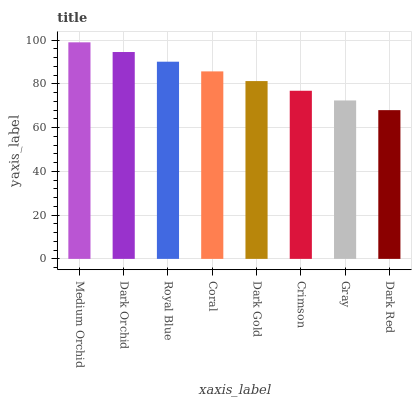Is Dark Red the minimum?
Answer yes or no. Yes. Is Medium Orchid the maximum?
Answer yes or no. Yes. Is Dark Orchid the minimum?
Answer yes or no. No. Is Dark Orchid the maximum?
Answer yes or no. No. Is Medium Orchid greater than Dark Orchid?
Answer yes or no. Yes. Is Dark Orchid less than Medium Orchid?
Answer yes or no. Yes. Is Dark Orchid greater than Medium Orchid?
Answer yes or no. No. Is Medium Orchid less than Dark Orchid?
Answer yes or no. No. Is Coral the high median?
Answer yes or no. Yes. Is Dark Gold the low median?
Answer yes or no. Yes. Is Crimson the high median?
Answer yes or no. No. Is Medium Orchid the low median?
Answer yes or no. No. 